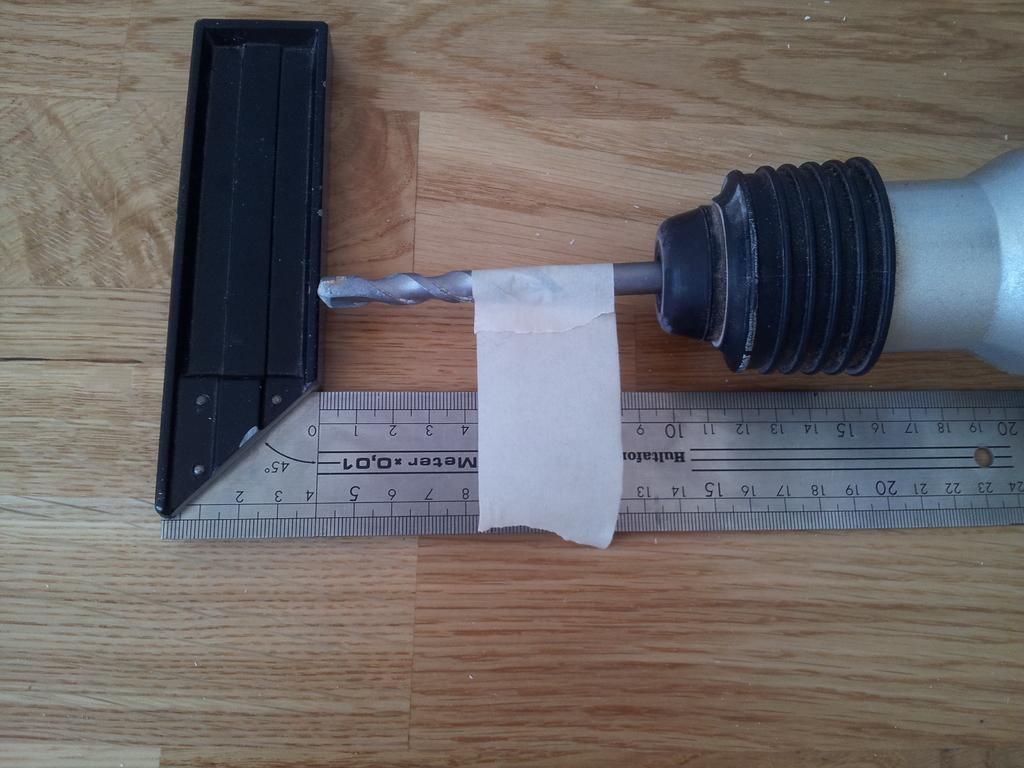<image>
Summarize the visual content of the image. A drill on the floor by a ruler that says Hultafor Masters and the drill bit has tape on the end 